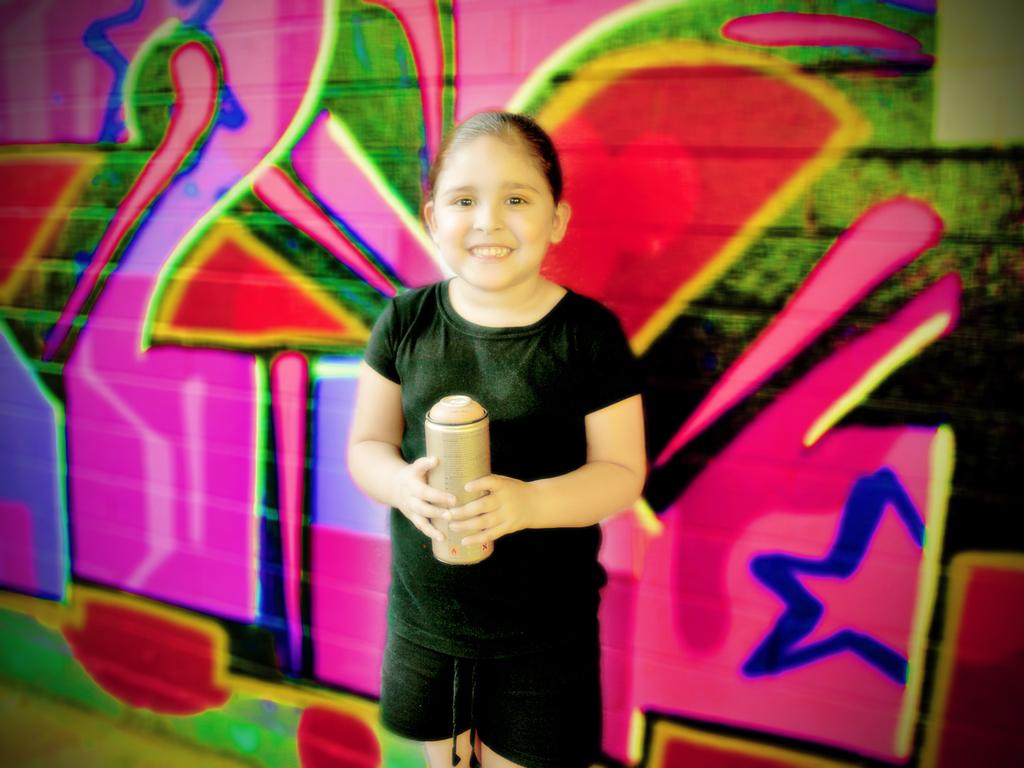Who is the main subject in the image? There is a girl in the image. What is the girl doing in the image? The girl is holding an object and smiling. What can be seen in the background of the image? There is a wall in the background of the image. Is there any artwork visible on the wall? Yes, there is a painting on the wall. Can you see any cracks in the painting on the wall? There is no information about cracks in the painting on the wall, as the facts provided do not mention any details about the painting's condition. Is there a ghost visible in the image? There is no mention of a ghost in the image, and no such figure can be seen in the provided facts. 